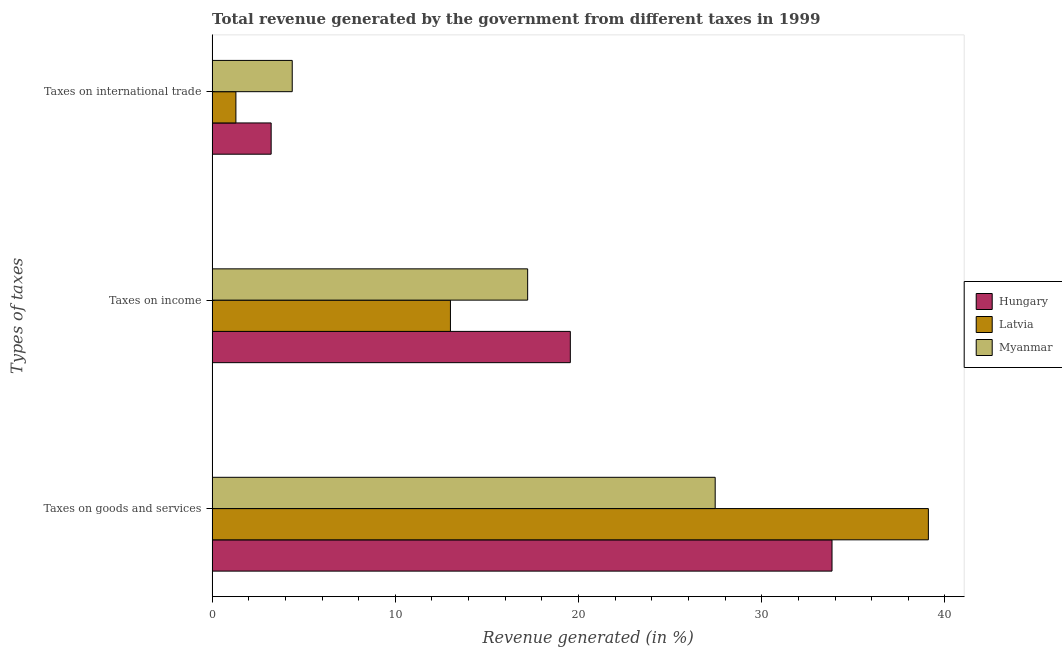How many different coloured bars are there?
Ensure brevity in your answer.  3. Are the number of bars per tick equal to the number of legend labels?
Ensure brevity in your answer.  Yes. What is the label of the 2nd group of bars from the top?
Provide a short and direct response. Taxes on income. What is the percentage of revenue generated by taxes on goods and services in Latvia?
Keep it short and to the point. 39.1. Across all countries, what is the maximum percentage of revenue generated by tax on international trade?
Keep it short and to the point. 4.37. Across all countries, what is the minimum percentage of revenue generated by tax on international trade?
Make the answer very short. 1.3. In which country was the percentage of revenue generated by taxes on goods and services maximum?
Ensure brevity in your answer.  Latvia. In which country was the percentage of revenue generated by taxes on goods and services minimum?
Your answer should be compact. Myanmar. What is the total percentage of revenue generated by taxes on income in the graph?
Offer a terse response. 49.78. What is the difference between the percentage of revenue generated by taxes on goods and services in Myanmar and that in Hungary?
Your response must be concise. -6.38. What is the difference between the percentage of revenue generated by taxes on income in Latvia and the percentage of revenue generated by tax on international trade in Hungary?
Offer a terse response. 9.79. What is the average percentage of revenue generated by taxes on goods and services per country?
Your answer should be compact. 33.46. What is the difference between the percentage of revenue generated by taxes on goods and services and percentage of revenue generated by taxes on income in Hungary?
Keep it short and to the point. 14.28. What is the ratio of the percentage of revenue generated by tax on international trade in Myanmar to that in Hungary?
Your answer should be very brief. 1.36. Is the percentage of revenue generated by tax on international trade in Myanmar less than that in Hungary?
Your response must be concise. No. What is the difference between the highest and the second highest percentage of revenue generated by tax on international trade?
Make the answer very short. 1.15. What is the difference between the highest and the lowest percentage of revenue generated by taxes on goods and services?
Your answer should be very brief. 11.64. What does the 2nd bar from the top in Taxes on international trade represents?
Offer a terse response. Latvia. What does the 1st bar from the bottom in Taxes on goods and services represents?
Keep it short and to the point. Hungary. What is the difference between two consecutive major ticks on the X-axis?
Give a very brief answer. 10. Are the values on the major ticks of X-axis written in scientific E-notation?
Provide a succinct answer. No. Does the graph contain any zero values?
Provide a short and direct response. No. Does the graph contain grids?
Offer a terse response. No. How are the legend labels stacked?
Ensure brevity in your answer.  Vertical. What is the title of the graph?
Keep it short and to the point. Total revenue generated by the government from different taxes in 1999. What is the label or title of the X-axis?
Offer a very short reply. Revenue generated (in %). What is the label or title of the Y-axis?
Provide a short and direct response. Types of taxes. What is the Revenue generated (in %) of Hungary in Taxes on goods and services?
Provide a succinct answer. 33.84. What is the Revenue generated (in %) of Latvia in Taxes on goods and services?
Your answer should be compact. 39.1. What is the Revenue generated (in %) of Myanmar in Taxes on goods and services?
Give a very brief answer. 27.46. What is the Revenue generated (in %) of Hungary in Taxes on income?
Your answer should be very brief. 19.55. What is the Revenue generated (in %) in Latvia in Taxes on income?
Provide a short and direct response. 13.01. What is the Revenue generated (in %) in Myanmar in Taxes on income?
Provide a short and direct response. 17.22. What is the Revenue generated (in %) of Hungary in Taxes on international trade?
Your answer should be very brief. 3.22. What is the Revenue generated (in %) of Latvia in Taxes on international trade?
Keep it short and to the point. 1.3. What is the Revenue generated (in %) of Myanmar in Taxes on international trade?
Provide a short and direct response. 4.37. Across all Types of taxes, what is the maximum Revenue generated (in %) in Hungary?
Give a very brief answer. 33.84. Across all Types of taxes, what is the maximum Revenue generated (in %) in Latvia?
Provide a short and direct response. 39.1. Across all Types of taxes, what is the maximum Revenue generated (in %) in Myanmar?
Keep it short and to the point. 27.46. Across all Types of taxes, what is the minimum Revenue generated (in %) in Hungary?
Provide a succinct answer. 3.22. Across all Types of taxes, what is the minimum Revenue generated (in %) of Latvia?
Offer a terse response. 1.3. Across all Types of taxes, what is the minimum Revenue generated (in %) in Myanmar?
Your response must be concise. 4.37. What is the total Revenue generated (in %) in Hungary in the graph?
Your answer should be very brief. 56.61. What is the total Revenue generated (in %) in Latvia in the graph?
Provide a short and direct response. 53.4. What is the total Revenue generated (in %) of Myanmar in the graph?
Offer a very short reply. 49.06. What is the difference between the Revenue generated (in %) of Hungary in Taxes on goods and services and that in Taxes on income?
Provide a short and direct response. 14.28. What is the difference between the Revenue generated (in %) of Latvia in Taxes on goods and services and that in Taxes on income?
Your response must be concise. 26.09. What is the difference between the Revenue generated (in %) in Myanmar in Taxes on goods and services and that in Taxes on income?
Ensure brevity in your answer.  10.24. What is the difference between the Revenue generated (in %) in Hungary in Taxes on goods and services and that in Taxes on international trade?
Your response must be concise. 30.61. What is the difference between the Revenue generated (in %) in Latvia in Taxes on goods and services and that in Taxes on international trade?
Make the answer very short. 37.8. What is the difference between the Revenue generated (in %) of Myanmar in Taxes on goods and services and that in Taxes on international trade?
Make the answer very short. 23.09. What is the difference between the Revenue generated (in %) in Hungary in Taxes on income and that in Taxes on international trade?
Ensure brevity in your answer.  16.33. What is the difference between the Revenue generated (in %) of Latvia in Taxes on income and that in Taxes on international trade?
Your answer should be compact. 11.71. What is the difference between the Revenue generated (in %) in Myanmar in Taxes on income and that in Taxes on international trade?
Your answer should be very brief. 12.85. What is the difference between the Revenue generated (in %) in Hungary in Taxes on goods and services and the Revenue generated (in %) in Latvia in Taxes on income?
Offer a terse response. 20.83. What is the difference between the Revenue generated (in %) of Hungary in Taxes on goods and services and the Revenue generated (in %) of Myanmar in Taxes on income?
Ensure brevity in your answer.  16.61. What is the difference between the Revenue generated (in %) of Latvia in Taxes on goods and services and the Revenue generated (in %) of Myanmar in Taxes on income?
Offer a terse response. 21.87. What is the difference between the Revenue generated (in %) of Hungary in Taxes on goods and services and the Revenue generated (in %) of Latvia in Taxes on international trade?
Provide a succinct answer. 32.54. What is the difference between the Revenue generated (in %) of Hungary in Taxes on goods and services and the Revenue generated (in %) of Myanmar in Taxes on international trade?
Your response must be concise. 29.46. What is the difference between the Revenue generated (in %) in Latvia in Taxes on goods and services and the Revenue generated (in %) in Myanmar in Taxes on international trade?
Provide a succinct answer. 34.72. What is the difference between the Revenue generated (in %) in Hungary in Taxes on income and the Revenue generated (in %) in Latvia in Taxes on international trade?
Offer a very short reply. 18.25. What is the difference between the Revenue generated (in %) in Hungary in Taxes on income and the Revenue generated (in %) in Myanmar in Taxes on international trade?
Ensure brevity in your answer.  15.18. What is the difference between the Revenue generated (in %) of Latvia in Taxes on income and the Revenue generated (in %) of Myanmar in Taxes on international trade?
Make the answer very short. 8.63. What is the average Revenue generated (in %) of Hungary per Types of taxes?
Your answer should be very brief. 18.87. What is the average Revenue generated (in %) in Latvia per Types of taxes?
Your answer should be compact. 17.8. What is the average Revenue generated (in %) of Myanmar per Types of taxes?
Keep it short and to the point. 16.35. What is the difference between the Revenue generated (in %) in Hungary and Revenue generated (in %) in Latvia in Taxes on goods and services?
Offer a very short reply. -5.26. What is the difference between the Revenue generated (in %) of Hungary and Revenue generated (in %) of Myanmar in Taxes on goods and services?
Your answer should be compact. 6.38. What is the difference between the Revenue generated (in %) of Latvia and Revenue generated (in %) of Myanmar in Taxes on goods and services?
Ensure brevity in your answer.  11.64. What is the difference between the Revenue generated (in %) of Hungary and Revenue generated (in %) of Latvia in Taxes on income?
Your response must be concise. 6.54. What is the difference between the Revenue generated (in %) in Hungary and Revenue generated (in %) in Myanmar in Taxes on income?
Your answer should be very brief. 2.33. What is the difference between the Revenue generated (in %) of Latvia and Revenue generated (in %) of Myanmar in Taxes on income?
Offer a very short reply. -4.22. What is the difference between the Revenue generated (in %) in Hungary and Revenue generated (in %) in Latvia in Taxes on international trade?
Make the answer very short. 1.92. What is the difference between the Revenue generated (in %) in Hungary and Revenue generated (in %) in Myanmar in Taxes on international trade?
Your response must be concise. -1.15. What is the difference between the Revenue generated (in %) of Latvia and Revenue generated (in %) of Myanmar in Taxes on international trade?
Your answer should be very brief. -3.07. What is the ratio of the Revenue generated (in %) of Hungary in Taxes on goods and services to that in Taxes on income?
Offer a terse response. 1.73. What is the ratio of the Revenue generated (in %) in Latvia in Taxes on goods and services to that in Taxes on income?
Make the answer very short. 3.01. What is the ratio of the Revenue generated (in %) of Myanmar in Taxes on goods and services to that in Taxes on income?
Your answer should be compact. 1.59. What is the ratio of the Revenue generated (in %) of Hungary in Taxes on goods and services to that in Taxes on international trade?
Offer a very short reply. 10.5. What is the ratio of the Revenue generated (in %) in Latvia in Taxes on goods and services to that in Taxes on international trade?
Offer a very short reply. 30.11. What is the ratio of the Revenue generated (in %) of Myanmar in Taxes on goods and services to that in Taxes on international trade?
Offer a very short reply. 6.28. What is the ratio of the Revenue generated (in %) in Hungary in Taxes on income to that in Taxes on international trade?
Keep it short and to the point. 6.07. What is the ratio of the Revenue generated (in %) of Latvia in Taxes on income to that in Taxes on international trade?
Offer a very short reply. 10.02. What is the ratio of the Revenue generated (in %) in Myanmar in Taxes on income to that in Taxes on international trade?
Provide a short and direct response. 3.94. What is the difference between the highest and the second highest Revenue generated (in %) of Hungary?
Your answer should be very brief. 14.28. What is the difference between the highest and the second highest Revenue generated (in %) of Latvia?
Your answer should be very brief. 26.09. What is the difference between the highest and the second highest Revenue generated (in %) in Myanmar?
Make the answer very short. 10.24. What is the difference between the highest and the lowest Revenue generated (in %) of Hungary?
Provide a succinct answer. 30.61. What is the difference between the highest and the lowest Revenue generated (in %) of Latvia?
Give a very brief answer. 37.8. What is the difference between the highest and the lowest Revenue generated (in %) in Myanmar?
Provide a short and direct response. 23.09. 